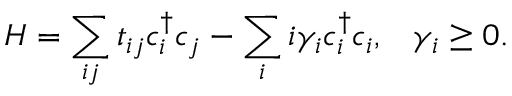<formula> <loc_0><loc_0><loc_500><loc_500>H = \sum _ { i j } t _ { i j } c _ { i } ^ { \dagger } c _ { j } - \sum _ { i } i \gamma _ { i } c _ { i } ^ { \dagger } c _ { i } , \, \gamma _ { i } \geq 0 .</formula> 